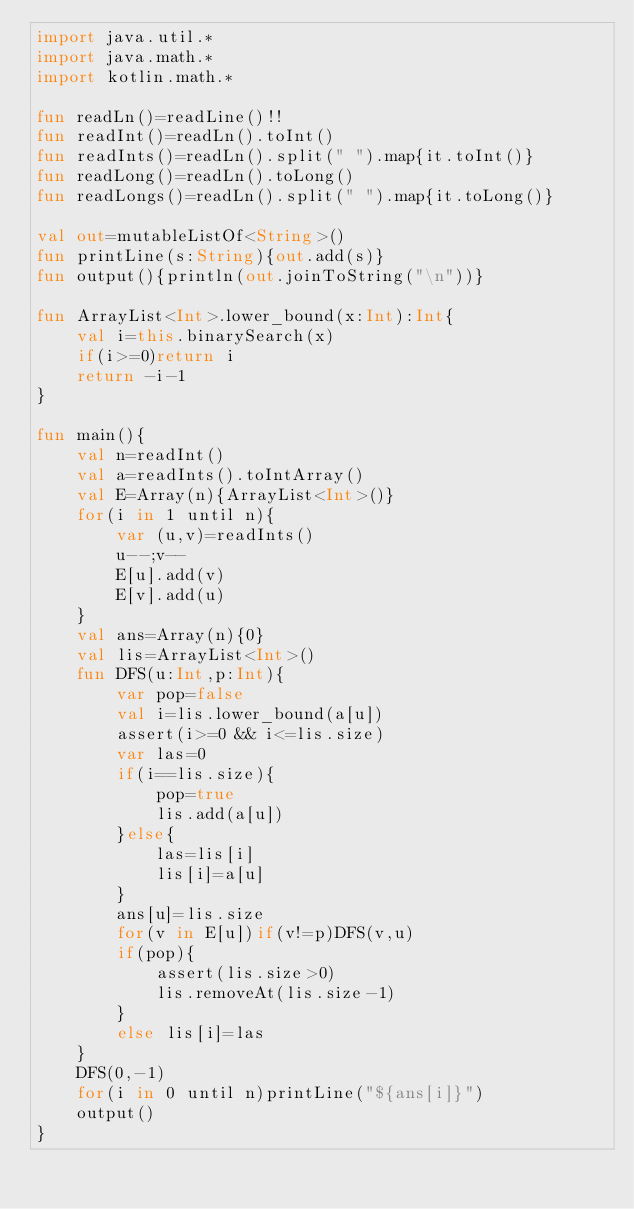Convert code to text. <code><loc_0><loc_0><loc_500><loc_500><_Kotlin_>import java.util.*
import java.math.*
import kotlin.math.*

fun readLn()=readLine()!!
fun readInt()=readLn().toInt()
fun readInts()=readLn().split(" ").map{it.toInt()}
fun readLong()=readLn().toLong()
fun readLongs()=readLn().split(" ").map{it.toLong()}

val out=mutableListOf<String>()
fun printLine(s:String){out.add(s)}
fun output(){println(out.joinToString("\n"))}

fun ArrayList<Int>.lower_bound(x:Int):Int{
    val i=this.binarySearch(x)
    if(i>=0)return i
    return -i-1
}

fun main(){
    val n=readInt()
    val a=readInts().toIntArray()
    val E=Array(n){ArrayList<Int>()}
    for(i in 1 until n){
        var (u,v)=readInts()
        u--;v--
        E[u].add(v)
        E[v].add(u)
    }
    val ans=Array(n){0}
    val lis=ArrayList<Int>()
    fun DFS(u:Int,p:Int){
        var pop=false
        val i=lis.lower_bound(a[u])
        assert(i>=0 && i<=lis.size)
        var las=0
        if(i==lis.size){
            pop=true
            lis.add(a[u])
        }else{
            las=lis[i]
            lis[i]=a[u]
        }
        ans[u]=lis.size
        for(v in E[u])if(v!=p)DFS(v,u)
        if(pop){
            assert(lis.size>0)
            lis.removeAt(lis.size-1)
        }
        else lis[i]=las
    }
    DFS(0,-1)
    for(i in 0 until n)printLine("${ans[i]}")
    output()
}</code> 